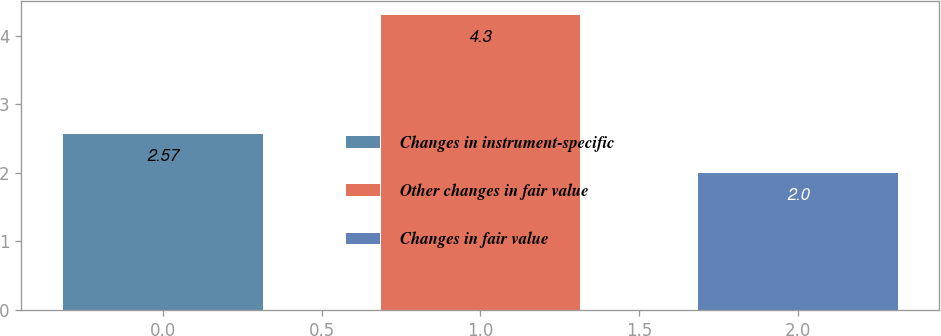Convert chart. <chart><loc_0><loc_0><loc_500><loc_500><bar_chart><fcel>Changes in instrument-specific<fcel>Other changes in fair value<fcel>Changes in fair value<nl><fcel>2.57<fcel>4.3<fcel>2<nl></chart> 